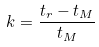Convert formula to latex. <formula><loc_0><loc_0><loc_500><loc_500>k = \frac { t _ { r } - t _ { M } } { t _ { M } }</formula> 